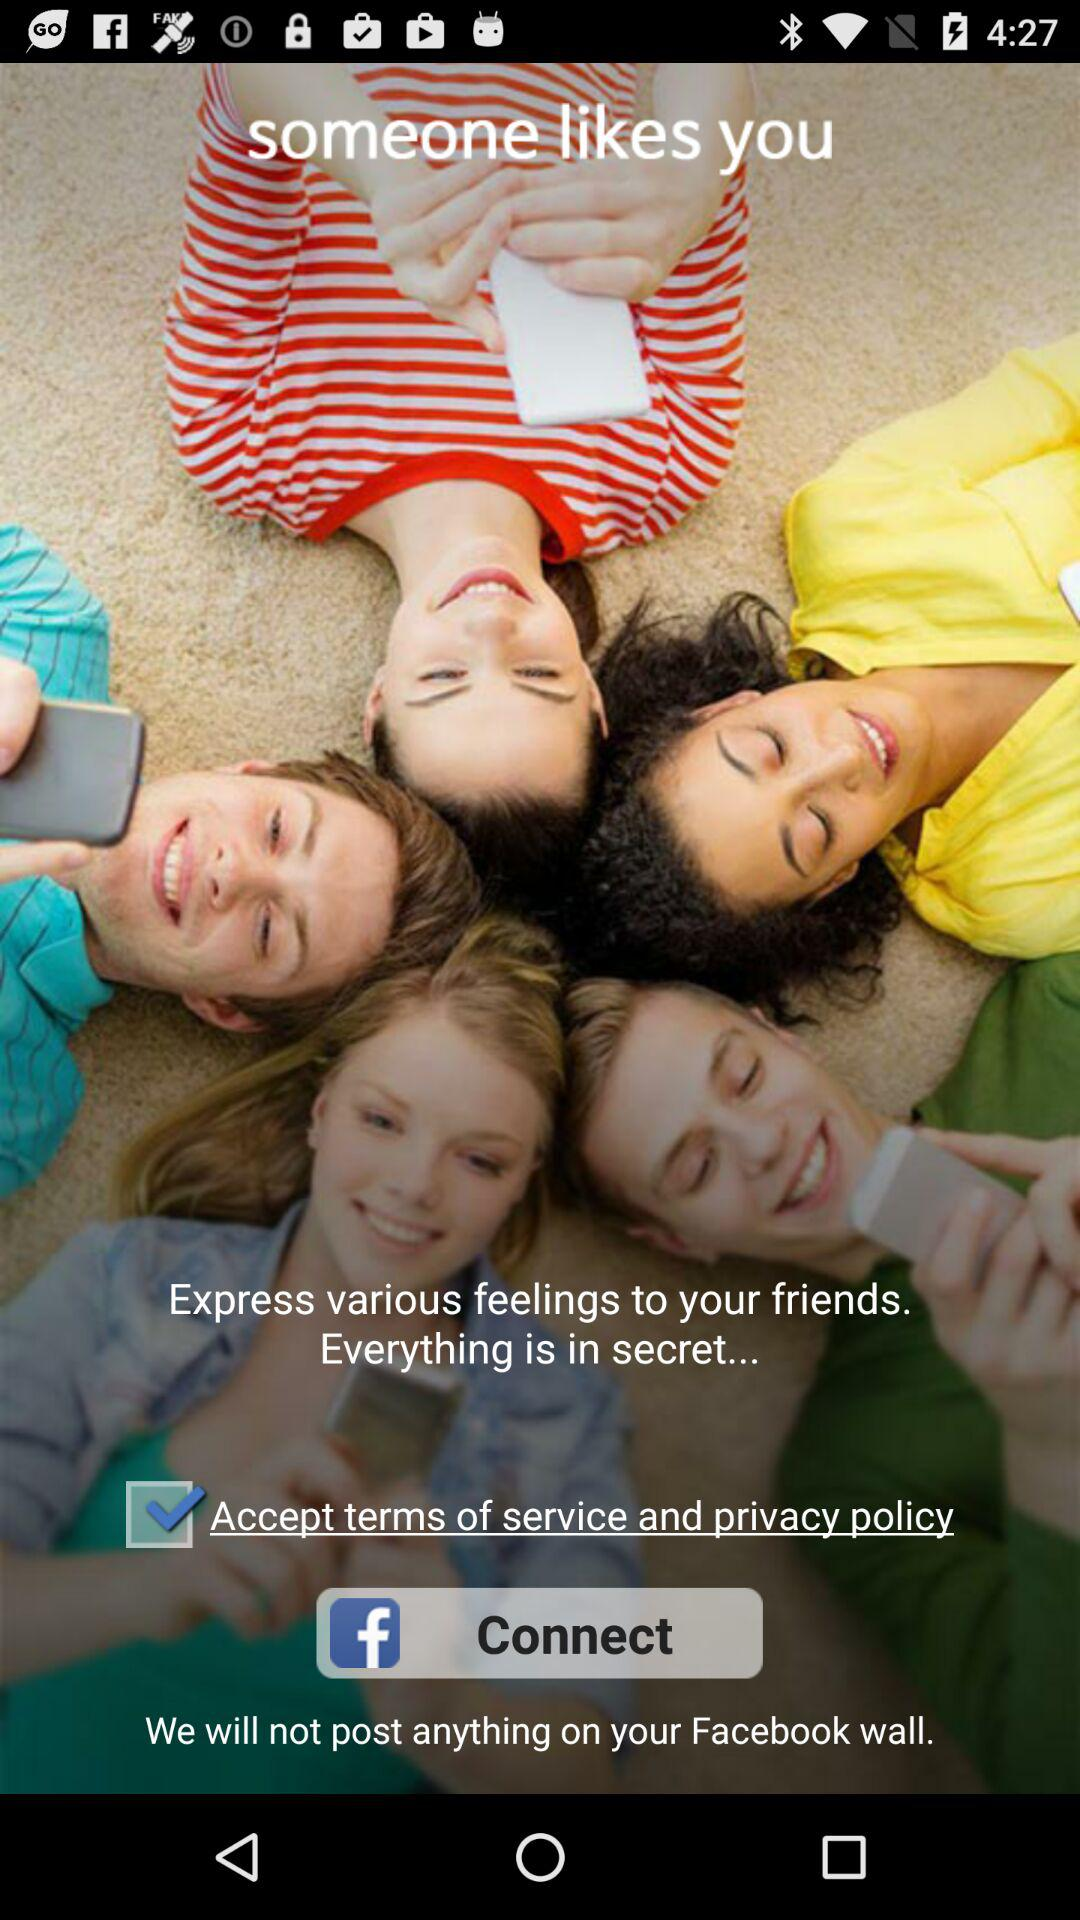Through what application can we connect? You can connect through "Facebook". 